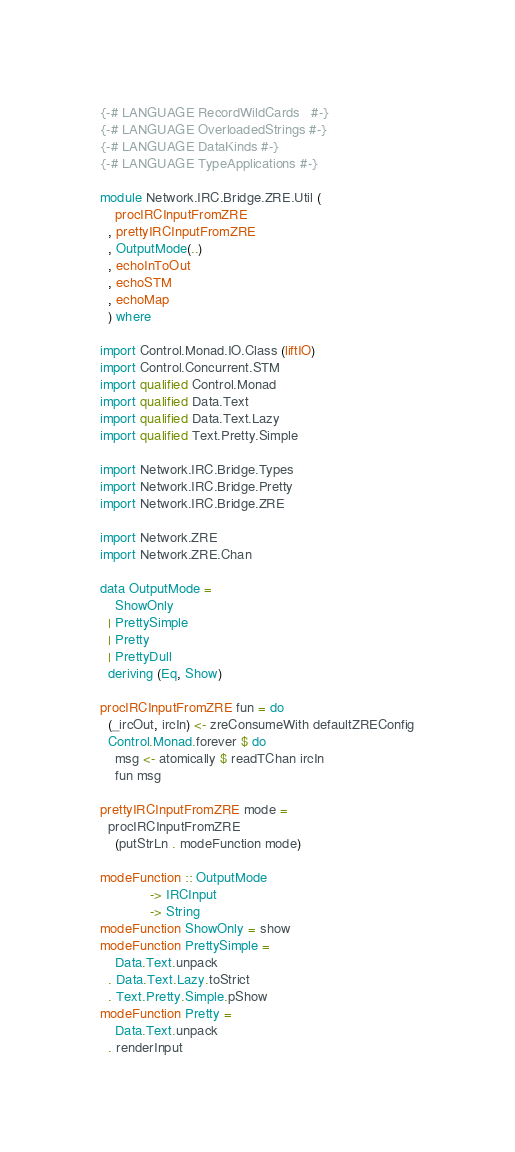Convert code to text. <code><loc_0><loc_0><loc_500><loc_500><_Haskell_>{-# LANGUAGE RecordWildCards   #-}
{-# LANGUAGE OverloadedStrings #-}
{-# LANGUAGE DataKinds #-}
{-# LANGUAGE TypeApplications #-}

module Network.IRC.Bridge.ZRE.Util (
    procIRCInputFromZRE
  , prettyIRCInputFromZRE
  , OutputMode(..)
  , echoInToOut
  , echoSTM
  , echoMap
  ) where

import Control.Monad.IO.Class (liftIO)
import Control.Concurrent.STM
import qualified Control.Monad
import qualified Data.Text
import qualified Data.Text.Lazy
import qualified Text.Pretty.Simple

import Network.IRC.Bridge.Types
import Network.IRC.Bridge.Pretty
import Network.IRC.Bridge.ZRE

import Network.ZRE
import Network.ZRE.Chan

data OutputMode =
    ShowOnly
  | PrettySimple
  | Pretty
  | PrettyDull
  deriving (Eq, Show)

procIRCInputFromZRE fun = do
  (_ircOut, ircIn) <- zreConsumeWith defaultZREConfig
  Control.Monad.forever $ do
    msg <- atomically $ readTChan ircIn
    fun msg

prettyIRCInputFromZRE mode =
  procIRCInputFromZRE
    (putStrLn . modeFunction mode)

modeFunction :: OutputMode
             -> IRCInput
             -> String
modeFunction ShowOnly = show
modeFunction PrettySimple =
    Data.Text.unpack
  . Data.Text.Lazy.toStrict
  . Text.Pretty.Simple.pShow
modeFunction Pretty =
    Data.Text.unpack
  . renderInput
</code> 